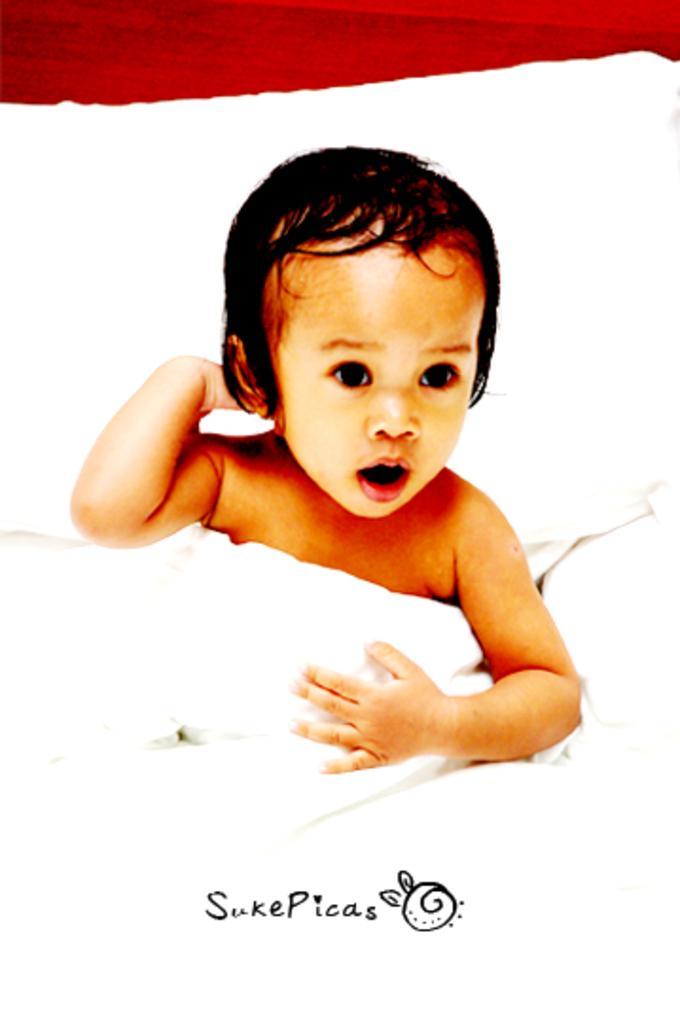In one or two sentences, can you explain what this image depicts? In this image we can see a baby on the bed. We can see some text at the bottom of the image. 